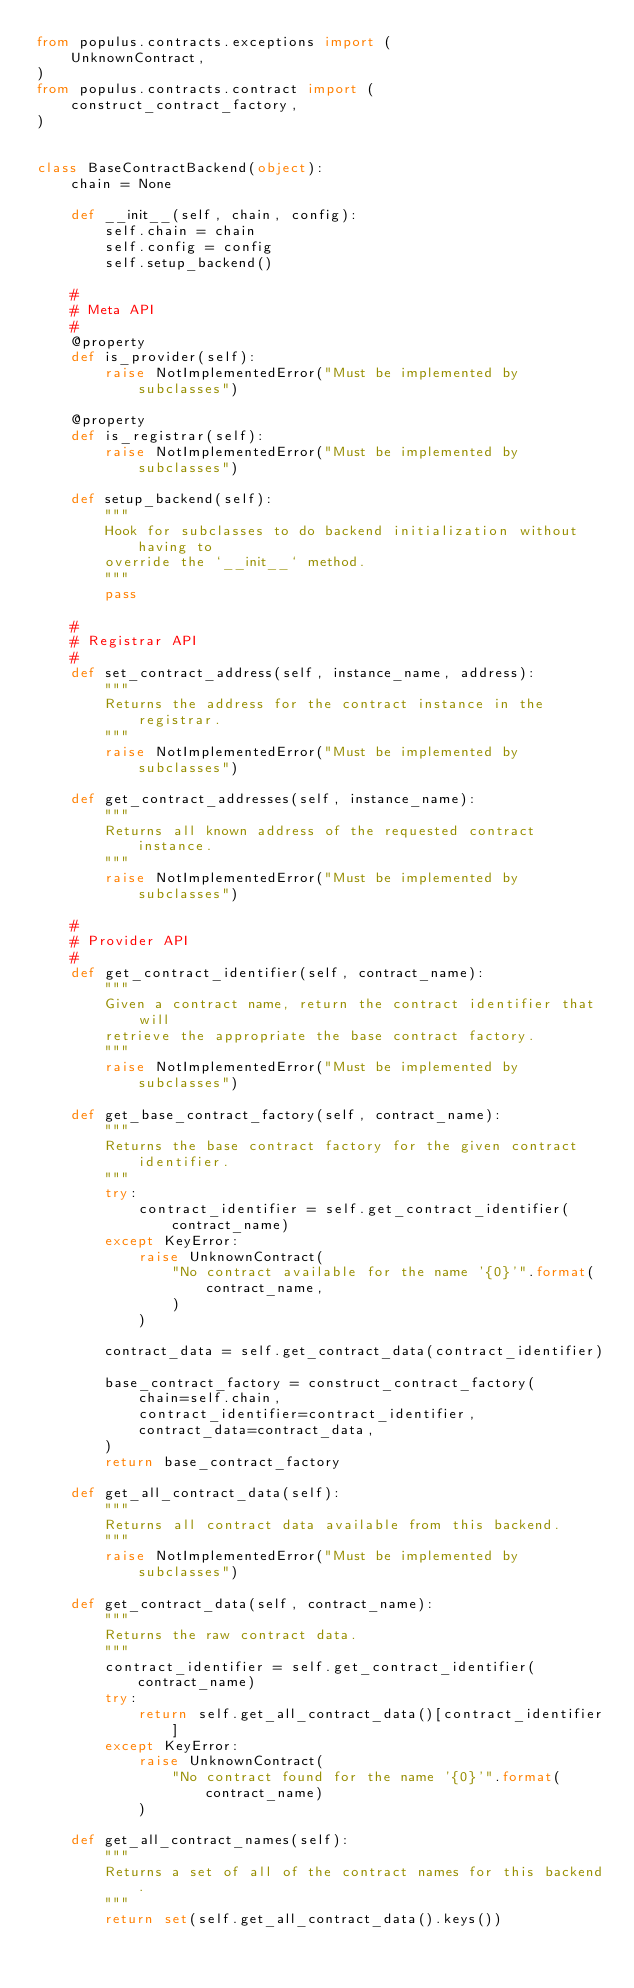Convert code to text. <code><loc_0><loc_0><loc_500><loc_500><_Python_>from populus.contracts.exceptions import (
    UnknownContract,
)
from populus.contracts.contract import (
    construct_contract_factory,
)


class BaseContractBackend(object):
    chain = None

    def __init__(self, chain, config):
        self.chain = chain
        self.config = config
        self.setup_backend()

    #
    # Meta API
    #
    @property
    def is_provider(self):
        raise NotImplementedError("Must be implemented by subclasses")

    @property
    def is_registrar(self):
        raise NotImplementedError("Must be implemented by subclasses")

    def setup_backend(self):
        """
        Hook for subclasses to do backend initialization without having to
        override the `__init__` method.
        """
        pass

    #
    # Registrar API
    #
    def set_contract_address(self, instance_name, address):
        """
        Returns the address for the contract instance in the registrar.
        """
        raise NotImplementedError("Must be implemented by subclasses")

    def get_contract_addresses(self, instance_name):
        """
        Returns all known address of the requested contract instance.
        """
        raise NotImplementedError("Must be implemented by subclasses")

    #
    # Provider API
    #
    def get_contract_identifier(self, contract_name):
        """
        Given a contract name, return the contract identifier that will
        retrieve the appropriate the base contract factory.
        """
        raise NotImplementedError("Must be implemented by subclasses")

    def get_base_contract_factory(self, contract_name):
        """
        Returns the base contract factory for the given contract identifier.
        """
        try:
            contract_identifier = self.get_contract_identifier(contract_name)
        except KeyError:
            raise UnknownContract(
                "No contract available for the name '{0}'".format(
                    contract_name,
                )
            )

        contract_data = self.get_contract_data(contract_identifier)

        base_contract_factory = construct_contract_factory(
            chain=self.chain,
            contract_identifier=contract_identifier,
            contract_data=contract_data,
        )
        return base_contract_factory

    def get_all_contract_data(self):
        """
        Returns all contract data available from this backend.
        """
        raise NotImplementedError("Must be implemented by subclasses")

    def get_contract_data(self, contract_name):
        """
        Returns the raw contract data.
        """
        contract_identifier = self.get_contract_identifier(contract_name)
        try:
            return self.get_all_contract_data()[contract_identifier]
        except KeyError:
            raise UnknownContract(
                "No contract found for the name '{0}'".format(contract_name)
            )

    def get_all_contract_names(self):
        """
        Returns a set of all of the contract names for this backend.
        """
        return set(self.get_all_contract_data().keys())
</code> 